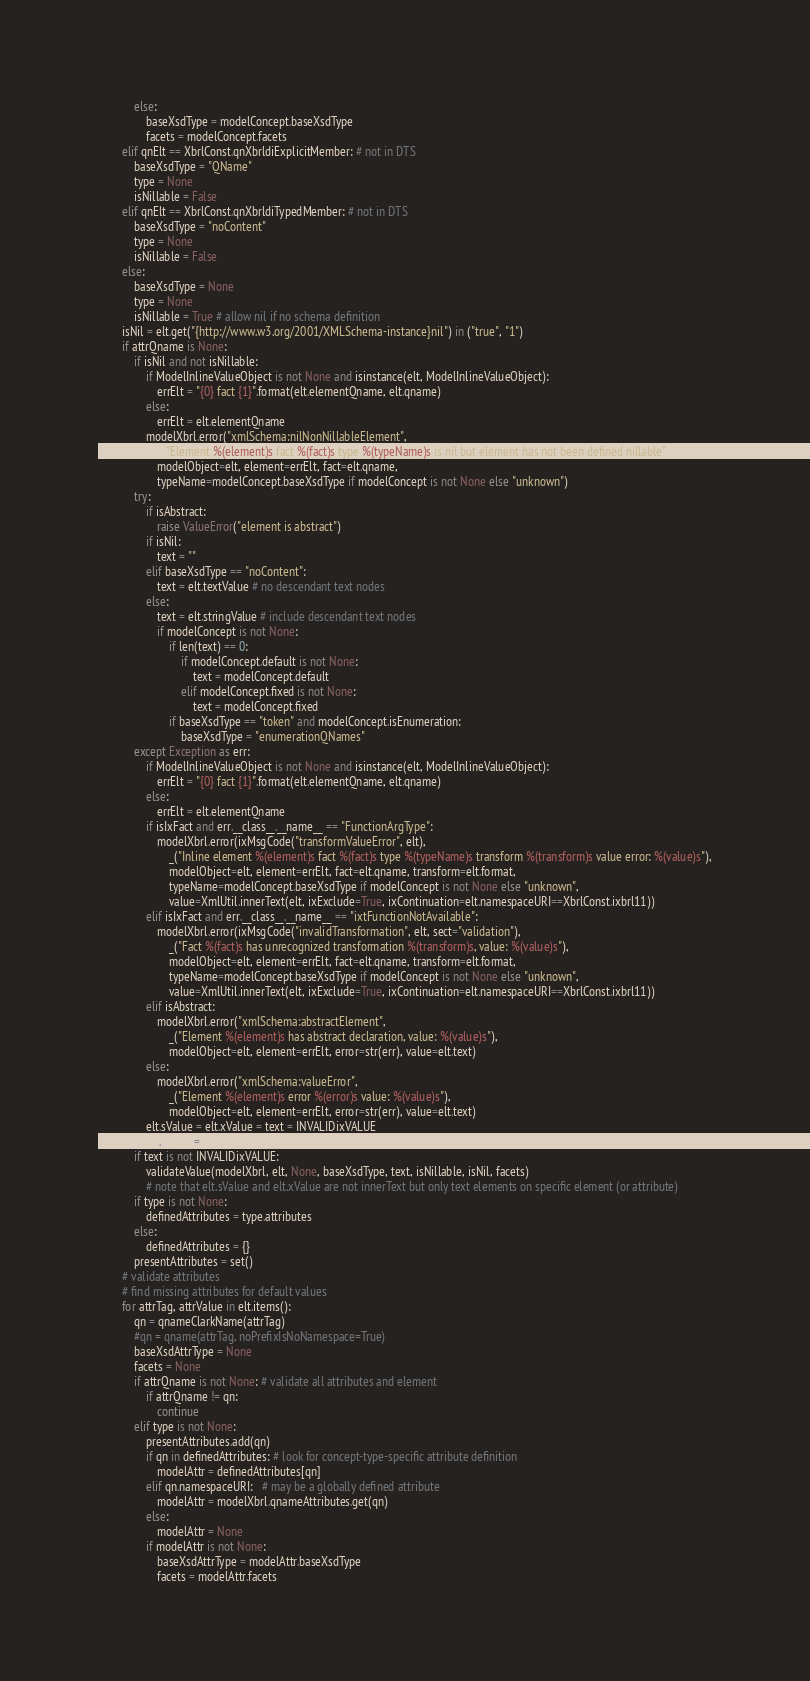Convert code to text. <code><loc_0><loc_0><loc_500><loc_500><_Python_>            else:
                baseXsdType = modelConcept.baseXsdType
                facets = modelConcept.facets
        elif qnElt == XbrlConst.qnXbrldiExplicitMember: # not in DTS
            baseXsdType = "QName"
            type = None
            isNillable = False
        elif qnElt == XbrlConst.qnXbrldiTypedMember: # not in DTS
            baseXsdType = "noContent"
            type = None
            isNillable = False
        else:
            baseXsdType = None
            type = None
            isNillable = True # allow nil if no schema definition
        isNil = elt.get("{http://www.w3.org/2001/XMLSchema-instance}nil") in ("true", "1")
        if attrQname is None:
            if isNil and not isNillable:
                if ModelInlineValueObject is not None and isinstance(elt, ModelInlineValueObject):
                    errElt = "{0} fact {1}".format(elt.elementQname, elt.qname)
                else:
                    errElt = elt.elementQname
                modelXbrl.error("xmlSchema:nilNonNillableElement",
                    _("Element %(element)s fact %(fact)s type %(typeName)s is nil but element has not been defined nillable"),
                    modelObject=elt, element=errElt, fact=elt.qname, 
                    typeName=modelConcept.baseXsdType if modelConcept is not None else "unknown")
            try:
                if isAbstract:
                    raise ValueError("element is abstract")
                if isNil:
                    text = ""
                elif baseXsdType == "noContent":
                    text = elt.textValue # no descendant text nodes
                else:
                    text = elt.stringValue # include descendant text nodes
                    if modelConcept is not None:
                        if len(text) == 0:
                            if modelConcept.default is not None:
                                text = modelConcept.default
                            elif modelConcept.fixed is not None:
                                text = modelConcept.fixed
                        if baseXsdType == "token" and modelConcept.isEnumeration:
                            baseXsdType = "enumerationQNames"
            except Exception as err:
                if ModelInlineValueObject is not None and isinstance(elt, ModelInlineValueObject):
                    errElt = "{0} fact {1}".format(elt.elementQname, elt.qname)
                else:
                    errElt = elt.elementQname
                if isIxFact and err.__class__.__name__ == "FunctionArgType":
                    modelXbrl.error(ixMsgCode("transformValueError", elt),
                        _("Inline element %(element)s fact %(fact)s type %(typeName)s transform %(transform)s value error: %(value)s"),
                        modelObject=elt, element=errElt, fact=elt.qname, transform=elt.format,
                        typeName=modelConcept.baseXsdType if modelConcept is not None else "unknown",
                        value=XmlUtil.innerText(elt, ixExclude=True, ixContinuation=elt.namespaceURI==XbrlConst.ixbrl11))
                elif isIxFact and err.__class__.__name__ == "ixtFunctionNotAvailable":
                    modelXbrl.error(ixMsgCode("invalidTransformation", elt, sect="validation"),
                        _("Fact %(fact)s has unrecognized transformation %(transform)s, value: %(value)s"),
                        modelObject=elt, element=errElt, fact=elt.qname, transform=elt.format,
                        typeName=modelConcept.baseXsdType if modelConcept is not None else "unknown",
                        value=XmlUtil.innerText(elt, ixExclude=True, ixContinuation=elt.namespaceURI==XbrlConst.ixbrl11))
                elif isAbstract:
                    modelXbrl.error("xmlSchema:abstractElement",
                        _("Element %(element)s has abstract declaration, value: %(value)s"),
                        modelObject=elt, element=errElt, error=str(err), value=elt.text)
                else:
                    modelXbrl.error("xmlSchema:valueError",
                        _("Element %(element)s error %(error)s value: %(value)s"),
                        modelObject=elt, element=errElt, error=str(err), value=elt.text)
                elt.sValue = elt.xValue = text = INVALIDixVALUE
                elt.xValid = INVALID
            if text is not INVALIDixVALUE:
                validateValue(modelXbrl, elt, None, baseXsdType, text, isNillable, isNil, facets)
                # note that elt.sValue and elt.xValue are not innerText but only text elements on specific element (or attribute)
            if type is not None:
                definedAttributes = type.attributes
            else:
                definedAttributes = {}
            presentAttributes = set()
        # validate attributes
        # find missing attributes for default values
        for attrTag, attrValue in elt.items():
            qn = qnameClarkName(attrTag)
            #qn = qname(attrTag, noPrefixIsNoNamespace=True)
            baseXsdAttrType = None
            facets = None
            if attrQname is not None: # validate all attributes and element
                if attrQname != qn:
                    continue
            elif type is not None:
                presentAttributes.add(qn)
                if qn in definedAttributes: # look for concept-type-specific attribute definition
                    modelAttr = definedAttributes[qn]
                elif qn.namespaceURI:   # may be a globally defined attribute
                    modelAttr = modelXbrl.qnameAttributes.get(qn)
                else:
                    modelAttr = None
                if modelAttr is not None:
                    baseXsdAttrType = modelAttr.baseXsdType
                    facets = modelAttr.facets</code> 